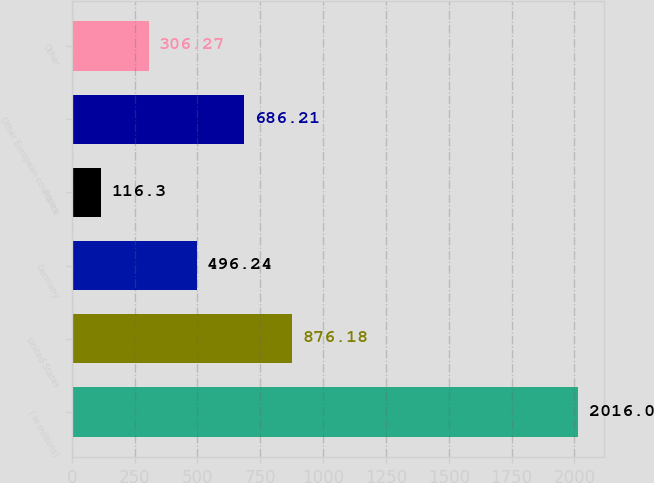Convert chart to OTSL. <chart><loc_0><loc_0><loc_500><loc_500><bar_chart><fcel>( in millions)<fcel>United States<fcel>Germany<fcel>France<fcel>Other European countries<fcel>Other<nl><fcel>2016<fcel>876.18<fcel>496.24<fcel>116.3<fcel>686.21<fcel>306.27<nl></chart> 